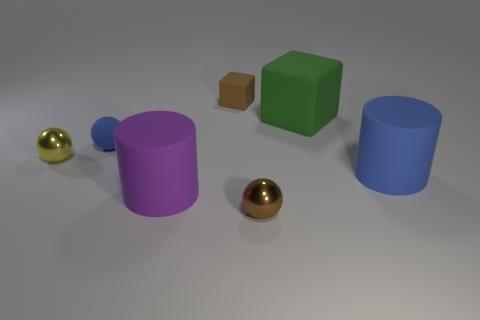How many small things are either matte things or blue objects?
Your response must be concise. 2. Is the material of the purple object the same as the brown cube?
Keep it short and to the point. Yes. There is a object that is the same color as the rubber sphere; what is its size?
Give a very brief answer. Large. Are there any small metallic objects of the same color as the small rubber block?
Provide a succinct answer. Yes. What size is the purple thing that is made of the same material as the green object?
Your answer should be very brief. Large. There is a blue rubber object that is in front of the small shiny ball that is behind the cylinder on the left side of the small brown rubber block; what shape is it?
Provide a short and direct response. Cylinder. The purple object that is the same shape as the large blue object is what size?
Give a very brief answer. Large. How big is the thing that is behind the tiny blue rubber sphere and left of the small brown shiny object?
Give a very brief answer. Small. What is the shape of the large object that is the same color as the small rubber sphere?
Your answer should be very brief. Cylinder. What is the color of the small rubber ball?
Provide a short and direct response. Blue. 